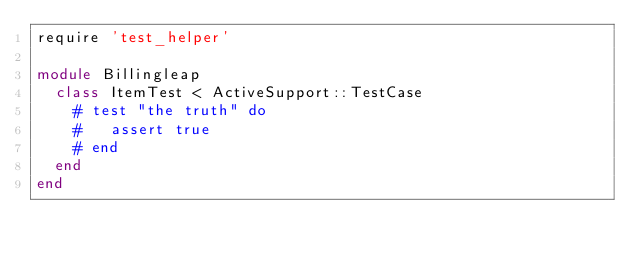Convert code to text. <code><loc_0><loc_0><loc_500><loc_500><_Ruby_>require 'test_helper'

module Billingleap
  class ItemTest < ActiveSupport::TestCase
    # test "the truth" do
    #   assert true
    # end
  end
end
</code> 